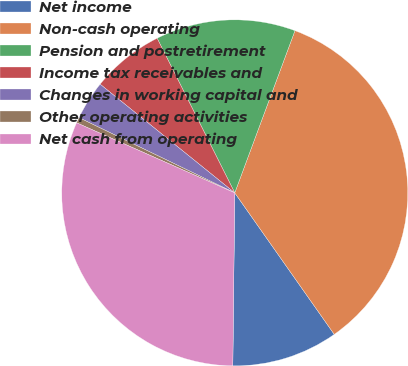<chart> <loc_0><loc_0><loc_500><loc_500><pie_chart><fcel>Net income<fcel>Non-cash operating<fcel>Pension and postretirement<fcel>Income tax receivables and<fcel>Changes in working capital and<fcel>Other operating activities<fcel>Net cash from operating<nl><fcel>9.93%<fcel>34.59%<fcel>13.06%<fcel>6.79%<fcel>3.65%<fcel>0.52%<fcel>31.46%<nl></chart> 